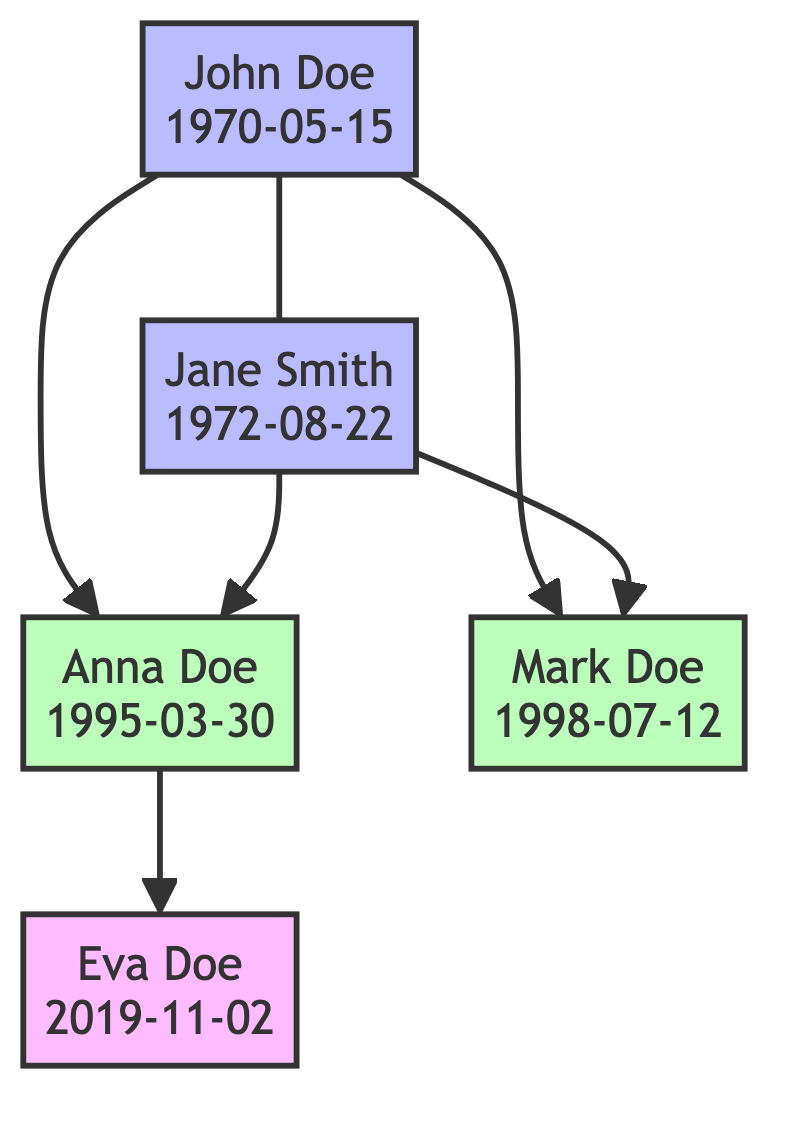What are the names of John Doe's spouse? In the diagram, John Doe is shown as having a marital relationship with Jane Smith, as represented by the line connecting them. This makes Jane Smith his spouse.
Answer: Jane Smith How many children do John and Jane have? John Doe and Jane Smith have two children, Anna Doe and Mark Doe, as shown by the lines connecting them to the parents.
Answer: 2 What is the birthdate of Anna Doe? The diagram specifies Anna Doe's birthdate as March 30, 1995, indicated next to her name within the node.
Answer: 1995-03-30 Who is the grandchild of John and Jane? Looking at the diagram, we see that Eva Doe is the child of Anna Doe, making her the grandchild of John and Jane, as implied by the connections.
Answer: Eva Doe How many generations are shown in the diagram? The diagram features three generations: John and Jane (1st generation), Anna and Mark (2nd generation), and Eva (3rd generation). This is determined by counting the parent-child relationships.
Answer: 3 Which child was born last? By reviewing the birthdates, Eva Doe, born on November 2, 2019, is the last child listed, making her the youngest.
Answer: Eva Doe What is the relationship between Mark Doe and Jane Smith? Mark Doe is a child of John Doe and Jane Smith, which means he is their son. This relationship is depicted by the connecting lines.
Answer: Son How many total individuals are presented in the diagram? The diagram has a total of five individuals, including parents, children, and a grandchild, identified as John, Jane, Anna, Mark, and Eva.
Answer: 5 What is the birthdate of the youngest grandchild? Eva Doe is the youngest grandchild, and her birthdate is presented in the diagram as November 2, 2019.
Answer: 2019-11-02 